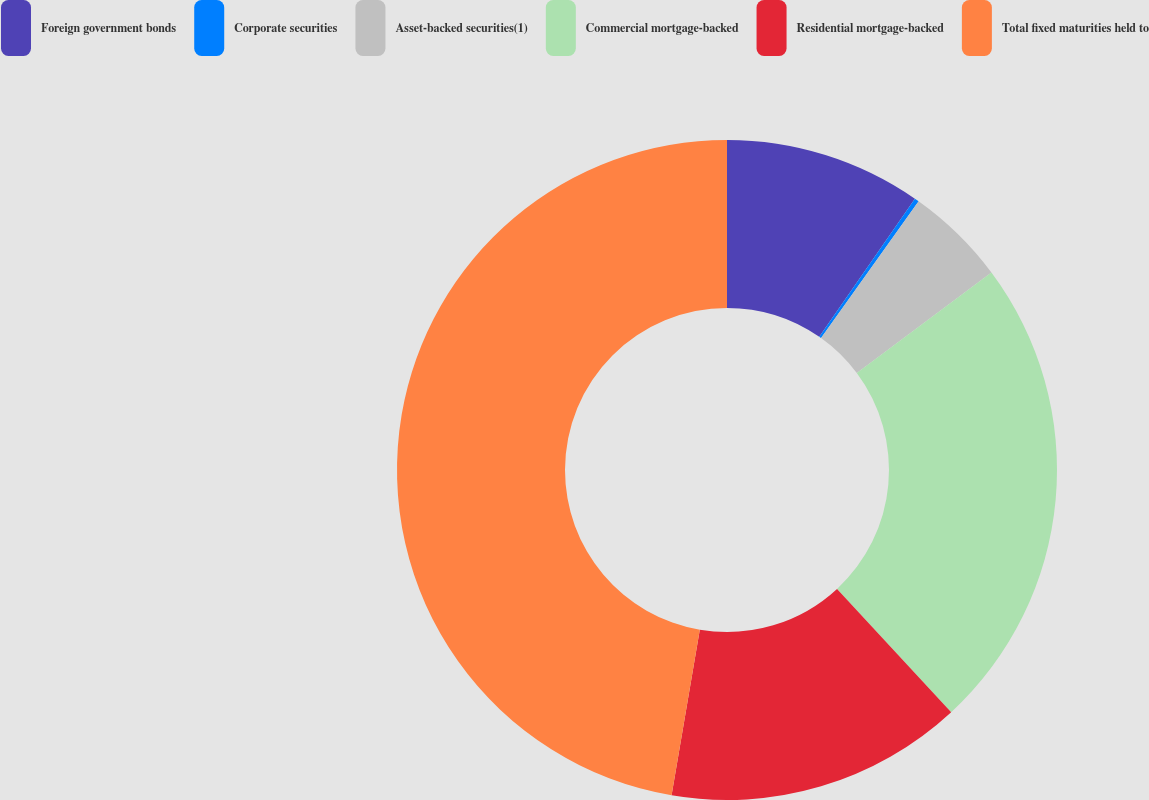Convert chart. <chart><loc_0><loc_0><loc_500><loc_500><pie_chart><fcel>Foreign government bonds<fcel>Corporate securities<fcel>Asset-backed securities(1)<fcel>Commercial mortgage-backed<fcel>Residential mortgage-backed<fcel>Total fixed maturities held to<nl><fcel>9.64%<fcel>0.22%<fcel>4.93%<fcel>23.32%<fcel>14.57%<fcel>47.31%<nl></chart> 